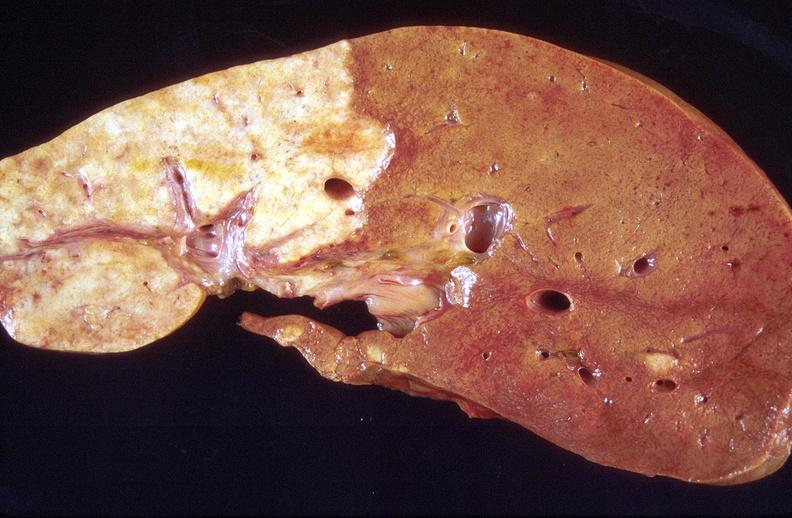what is present?
Answer the question using a single word or phrase. Liver 